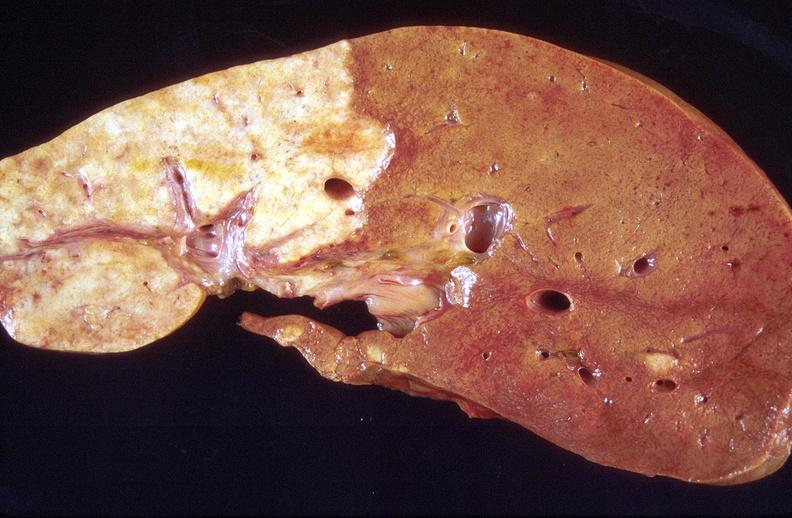what is present?
Answer the question using a single word or phrase. Liver 